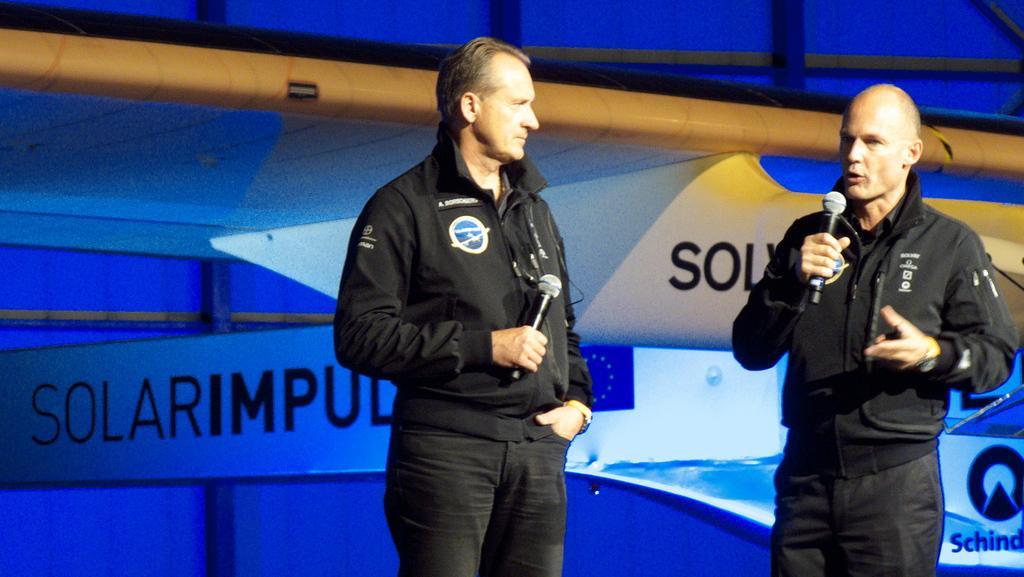Describe this image in one or two sentences. In this image I can see two people holding the mikes. I can see the boards with some text written on it. In the background, I can see the wall. 